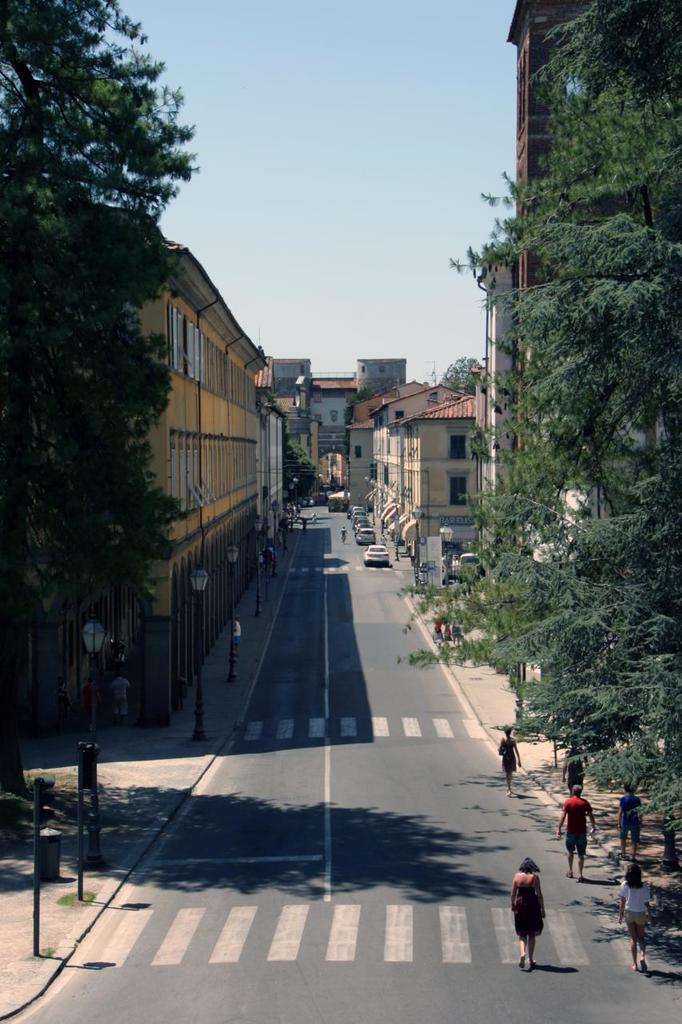In one or two sentences, can you explain what this image depicts? In this picture there are buildings and trees and there are street lights on the footpath and there are vehicles on the road. In foreground there are group of people walking. At the top there is sky. At the bottom there is a road. 